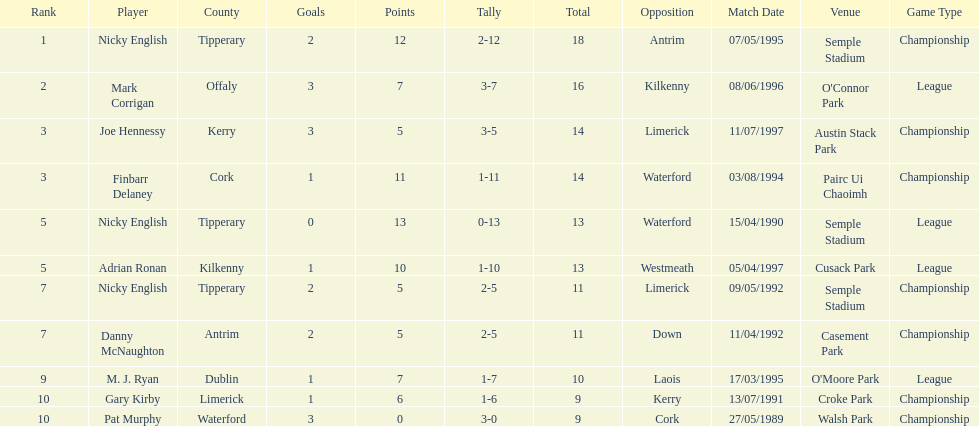Can you provide the count of people present in the list? 9. 